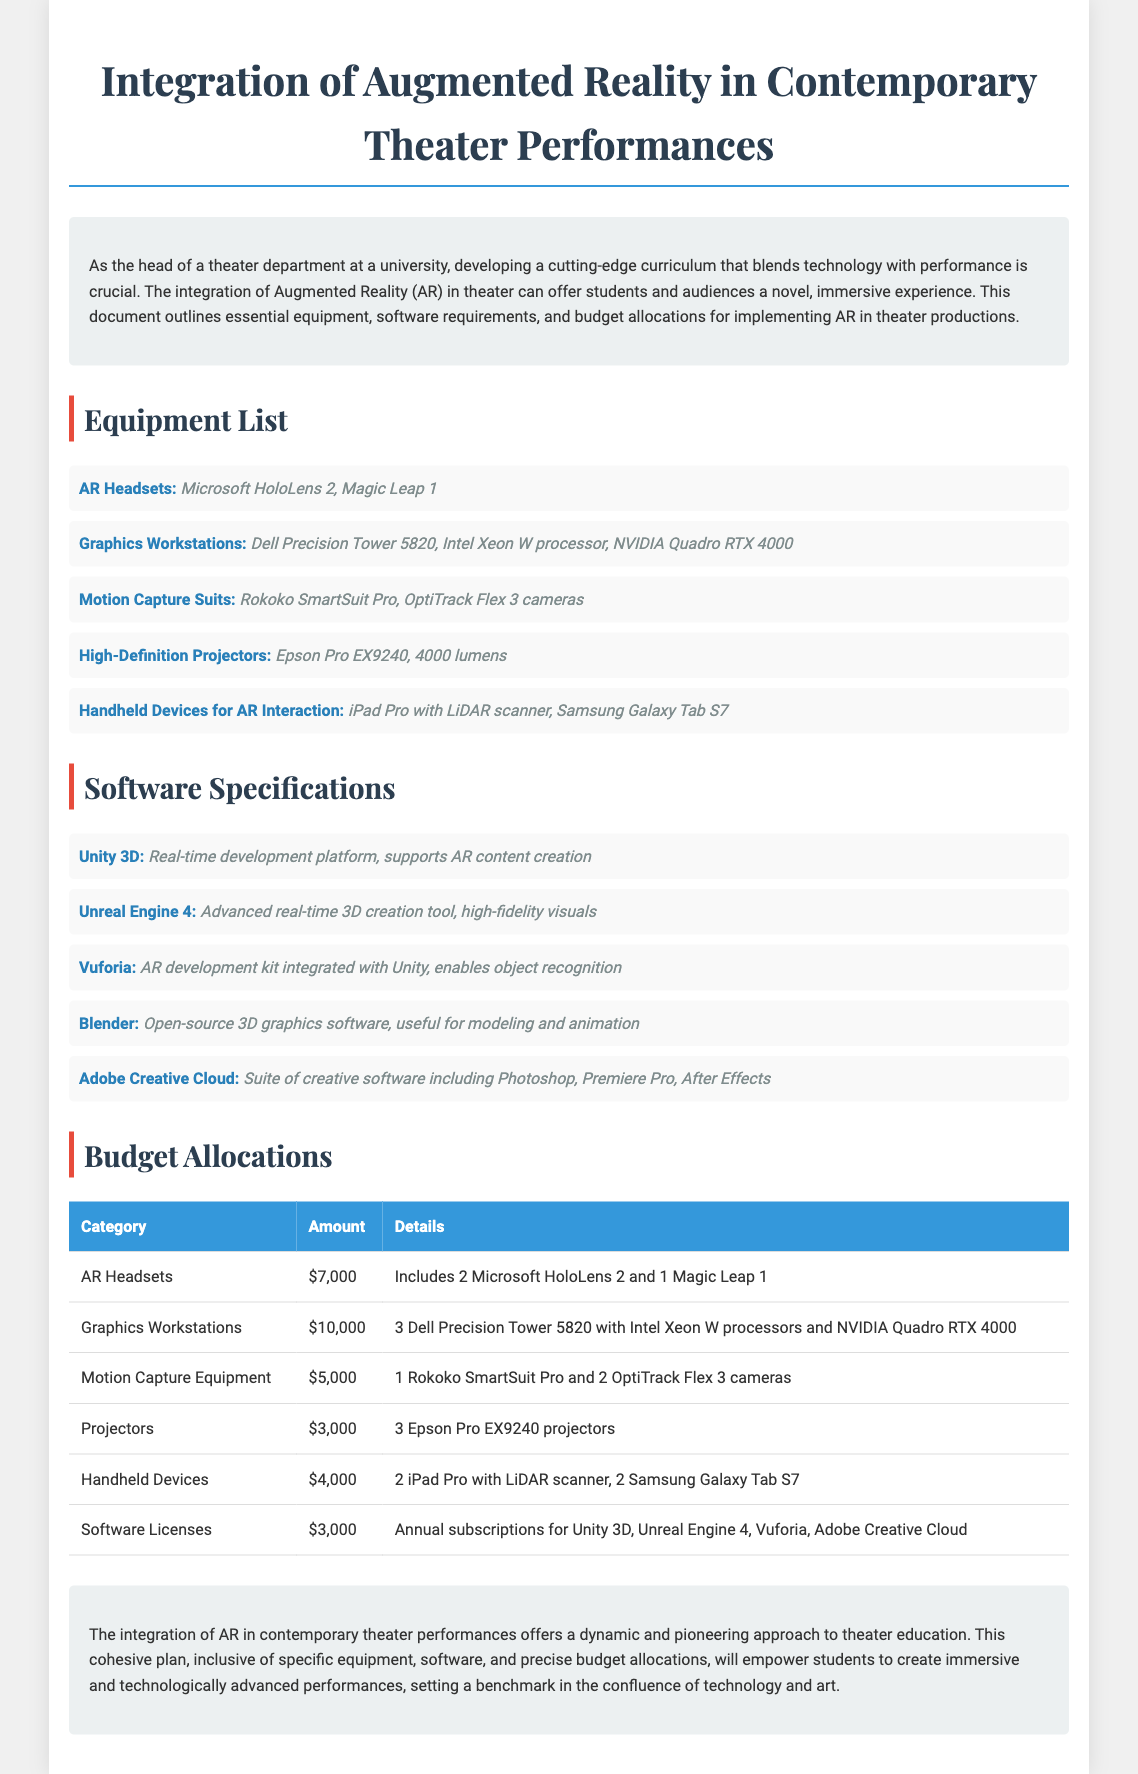What is the title of the document? The title of the document is stated prominently at the top and provides the main subject of the content.
Answer: Integration of Augmented Reality in Contemporary Theater Performances How many AR headsets are included in the budget? The document specifies the number of headsets in the budget allocation section under AR Headsets.
Answer: 3 What is the total budget allocation for graphics workstations? The budget allocation section provides the exact amount allocated for graphics workstations.
Answer: $10,000 Which software is used for real-time AR content creation? The document lists Unity 3D specifically as the platform for real-time AR content creation under software specifications.
Answer: Unity 3D What is the amount allocated for handheld devices? The budget allocation table indicates the specific amount set aside for handheld devices.
Answer: $4,000 Why is the integration of AR considered dynamic? The conclusion summarizes the benefits of AR integration in theater; this requires an understanding of the overall purpose described in the document.
Answer: Immersive experiences Which projectors are specified in the equipment list? The equipment section notes the specific model of projectors recommended for use.
Answer: Epson Pro EX9240 What type of motion capture suit is mentioned? The equipment list directly states the name of the motion capture suit included in the recommendations.
Answer: Rokoko SmartSuit Pro How many software licenses are allocated in the budget? The software licenses section implies annual subscriptions for multiple software, indicating each of them has a specific use case; calculating the direct number may require summarizing but the document states the allocation rather than the number of licenses directly.
Answer: $3,000 